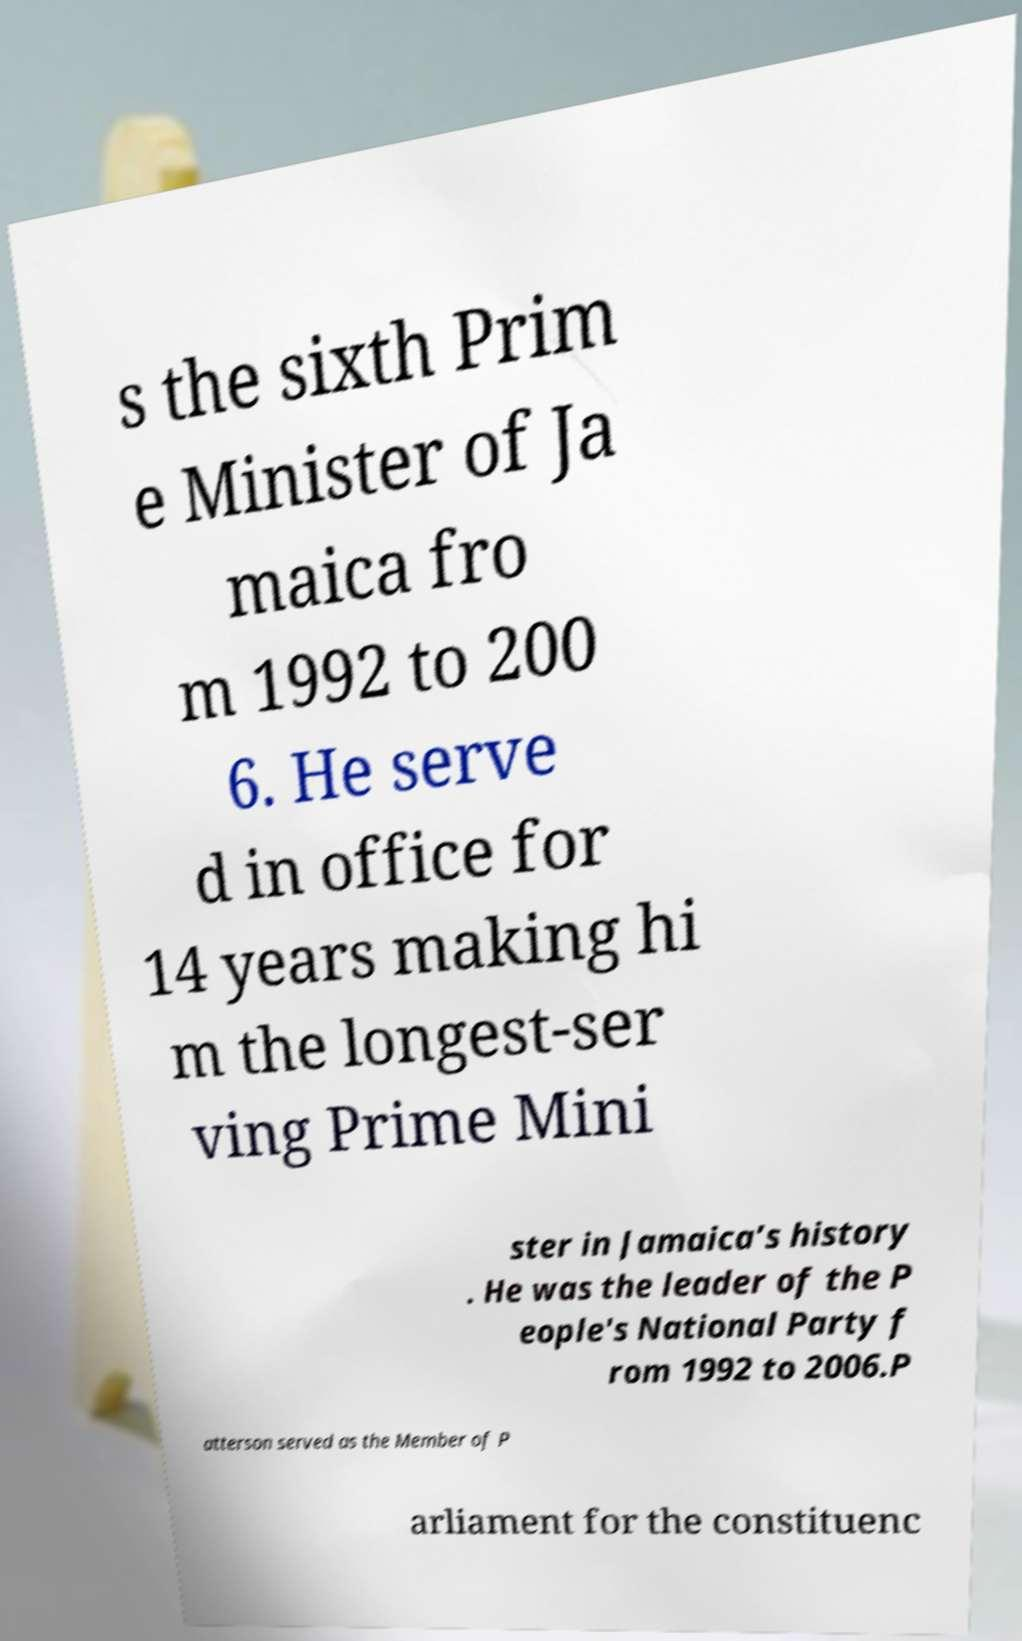Could you assist in decoding the text presented in this image and type it out clearly? s the sixth Prim e Minister of Ja maica fro m 1992 to 200 6. He serve d in office for 14 years making hi m the longest-ser ving Prime Mini ster in Jamaica’s history . He was the leader of the P eople's National Party f rom 1992 to 2006.P atterson served as the Member of P arliament for the constituenc 